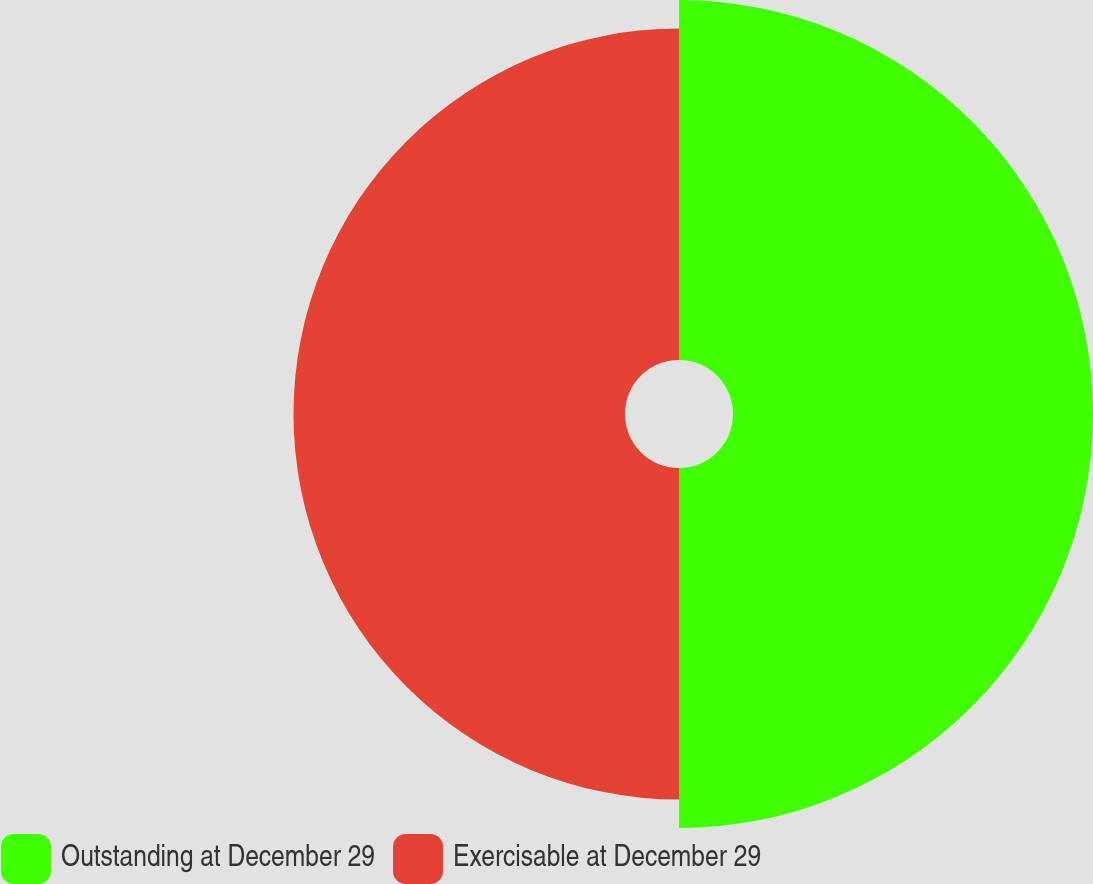<chart> <loc_0><loc_0><loc_500><loc_500><pie_chart><fcel>Outstanding at December 29<fcel>Exercisable at December 29<nl><fcel>52.06%<fcel>47.94%<nl></chart> 